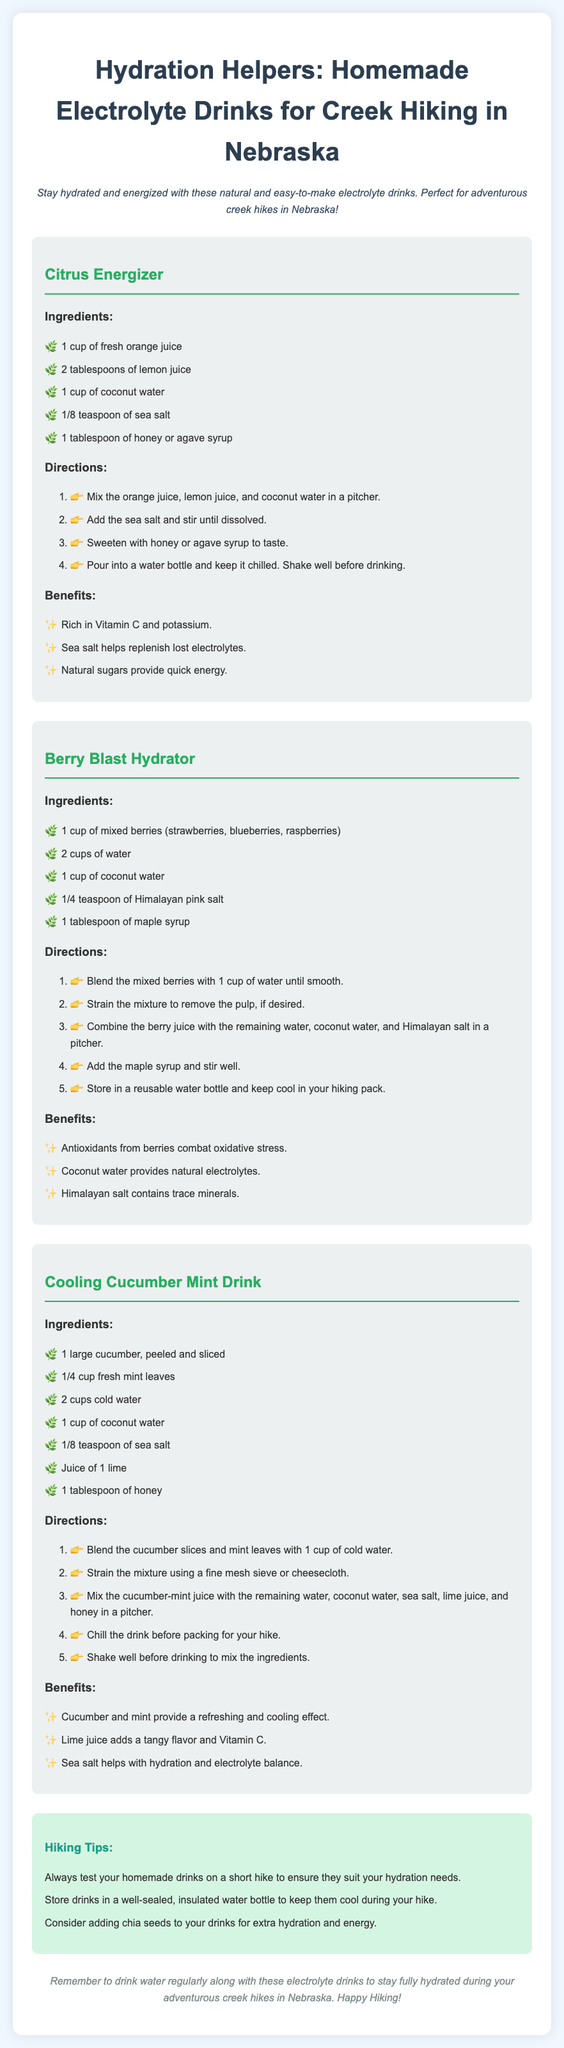What is the title of the document? The title of the document is presented prominently at the top, stating the subject matter clearly.
Answer: Hydration Helpers: Homemade Electrolyte Drinks for Creek Hiking in Nebraska What is one ingredient in the Citrus Energizer? The ingredients for the Citrus Energizer are listed under its respective section.
Answer: Fresh orange juice How many tablespoons of honey are used in the Cooling Cucumber Mint Drink? The Cooling Cucumber Mint Drink recipe specifies the amount of honey needed in the ingredients section.
Answer: 1 tablespoon What are the benefits of the Berry Blast Hydrator? The benefits are detailed in the benefits section of the recipe, summarizing its health effects.
Answer: Antioxidants from berries combat oxidative stress, Coconut water provides natural electrolytes, Himalayan salt contains trace minerals What is the main purpose of these recipes? The document provides an introductory statement describing the intent behind the recipes.
Answer: Stay hydrated and energized How much coconut water is used in the Berry Blast Hydrator? The amount of coconut water for this specific drink is clearly stated in the ingredients list.
Answer: 1 cup What is a suggested tip for hiking? The tips for hiking are outlined in a specific section, providing practical advice for readers.
Answer: Always test your homemade drinks on a short hike to ensure they suit your hydration needs What type of drink is the Cooling Cucumber Mint Drink? The document categorizes this recipe under its respective title of drink.
Answer: Hydration solution How should the citrus drink be stored before consumption? The directions provide specific instructions on how to prepare and store the drink.
Answer: Keep it chilled 